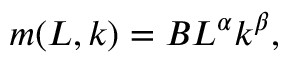<formula> <loc_0><loc_0><loc_500><loc_500>m ( L , k ) = B L ^ { \alpha } k ^ { \beta } ,</formula> 